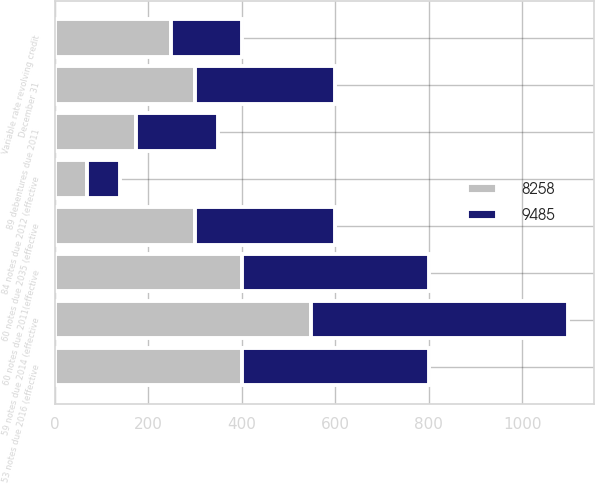Convert chart to OTSL. <chart><loc_0><loc_0><loc_500><loc_500><stacked_bar_chart><ecel><fcel>December 31<fcel>89 debentures due 2011<fcel>53 notes due 2016 (effective<fcel>60 notes due 2035 (effective<fcel>60 notes due 2011(effective<fcel>84 notes due 2012 (effective<fcel>Variable rate revolving credit<fcel>59 notes due 2014 (effective<nl><fcel>9485<fcel>300<fcel>175<fcel>400<fcel>300<fcel>400<fcel>70<fcel>150<fcel>549<nl><fcel>8258<fcel>300<fcel>175<fcel>400<fcel>300<fcel>400<fcel>70<fcel>250<fcel>549<nl></chart> 